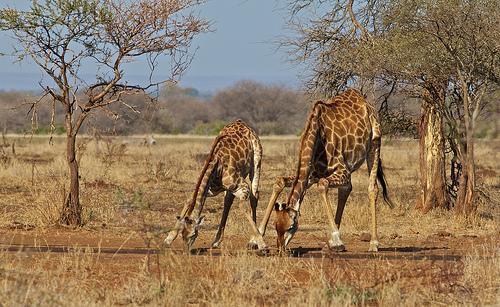How many giraffes are in the picture?
Give a very brief answer. 2. 